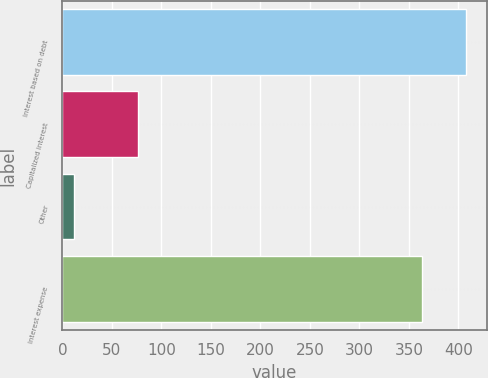<chart> <loc_0><loc_0><loc_500><loc_500><bar_chart><fcel>Interest based on debt<fcel>Capitalized interest<fcel>Other<fcel>Interest expense<nl><fcel>408<fcel>76<fcel>12<fcel>363<nl></chart> 